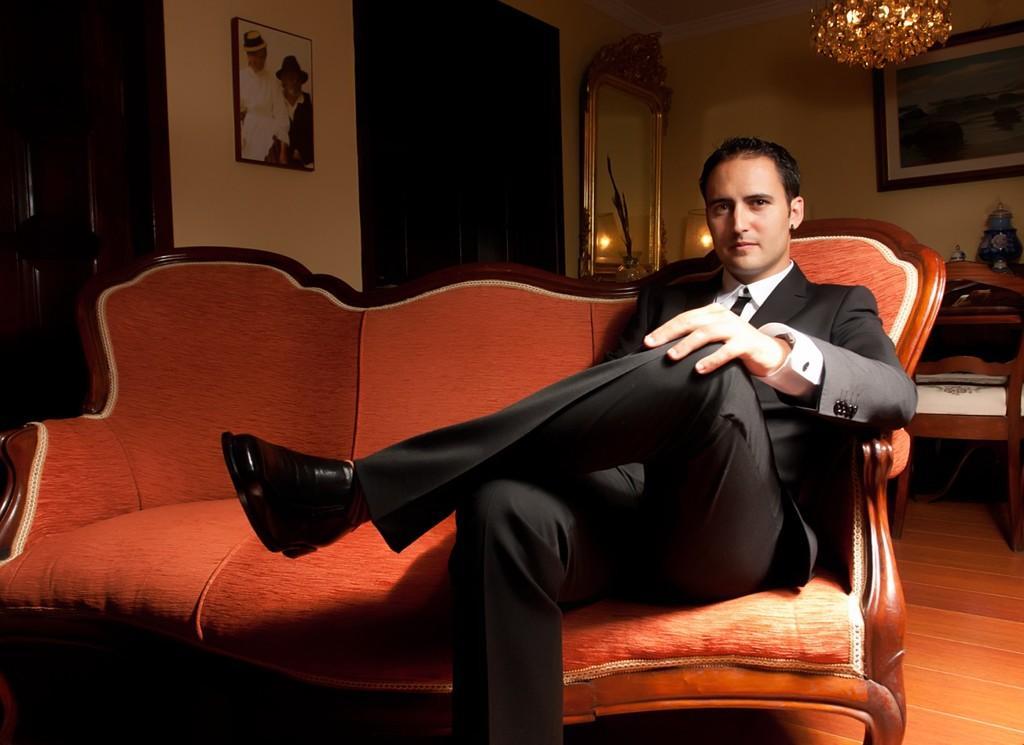Can you describe this image briefly? At the bottom of the image, there is a sofa of orange color on which a person is sitting, who's wearing a black color suit. Both side of the image, there is a wall of cream in color and a wall painting is there on it. On the right top, there is a chandelier hangs. In the middle right, mirror is there. This image is taken inside a room. 